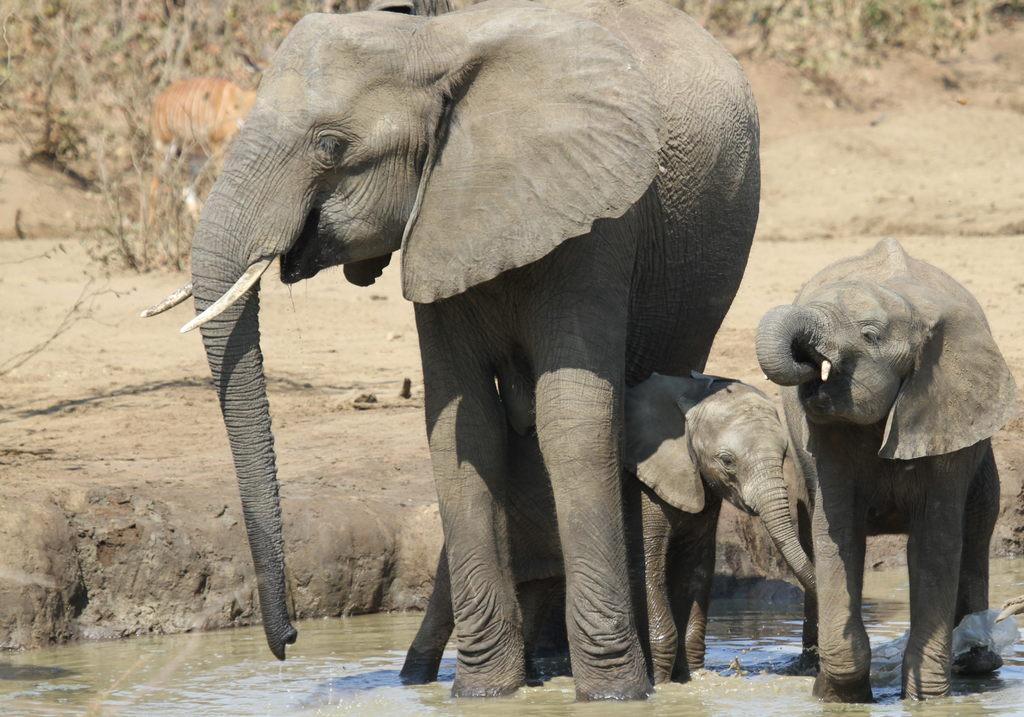How many elephants are in the water in the image? There are three elephants in the water in the image. What other animal can be seen in the image? There is a deer in the background of the image. What is the condition of the plants on the ground? The plants on the ground are dried. What type of cork can be seen floating near the elephants in the image? There is no cork present in the image; it features three elephants in the water and a deer in the background. 